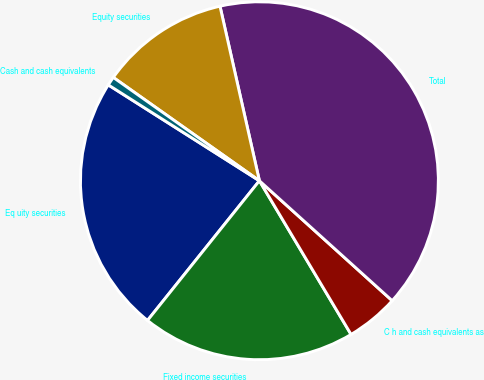Convert chart. <chart><loc_0><loc_0><loc_500><loc_500><pie_chart><fcel>Eq uity securities<fcel>Fixed income securities<fcel>C h and cash equivalents as<fcel>Total<fcel>Equity securities<fcel>Cash and cash equivalents<nl><fcel>23.25%<fcel>19.31%<fcel>4.75%<fcel>40.23%<fcel>11.67%<fcel>0.8%<nl></chart> 